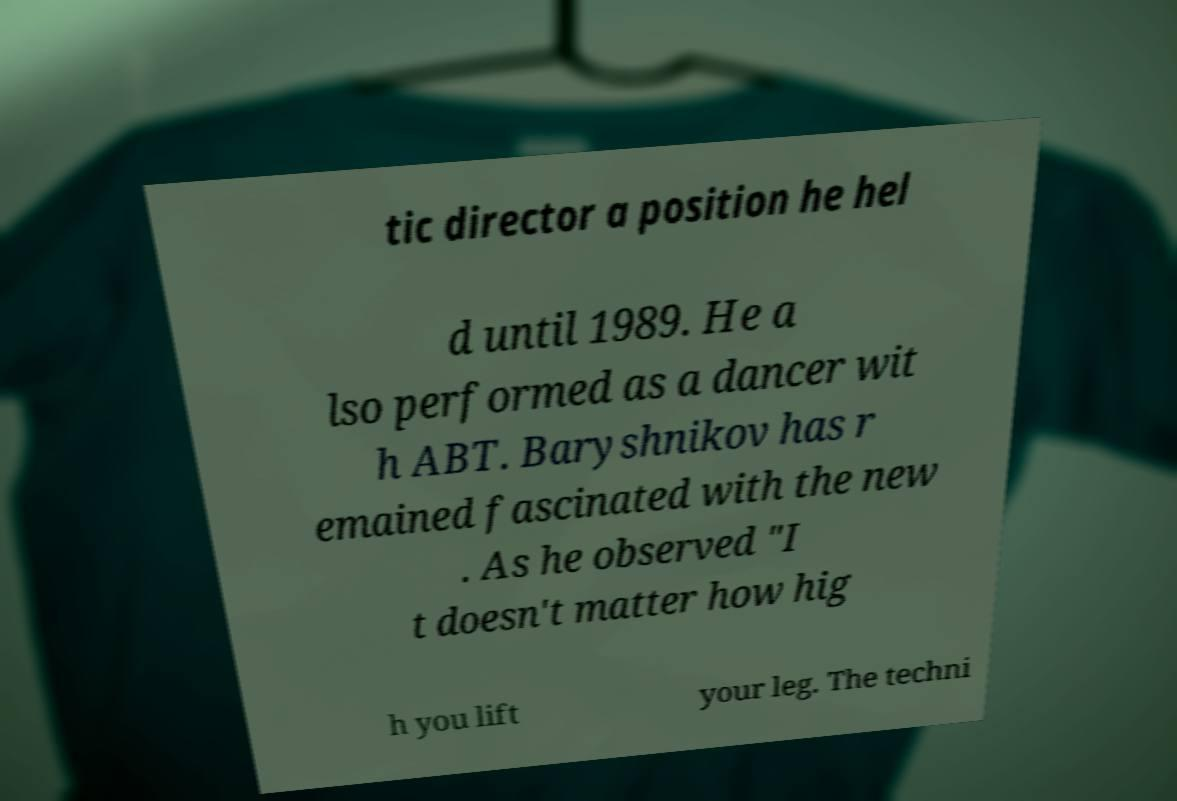Could you extract and type out the text from this image? tic director a position he hel d until 1989. He a lso performed as a dancer wit h ABT. Baryshnikov has r emained fascinated with the new . As he observed "I t doesn't matter how hig h you lift your leg. The techni 